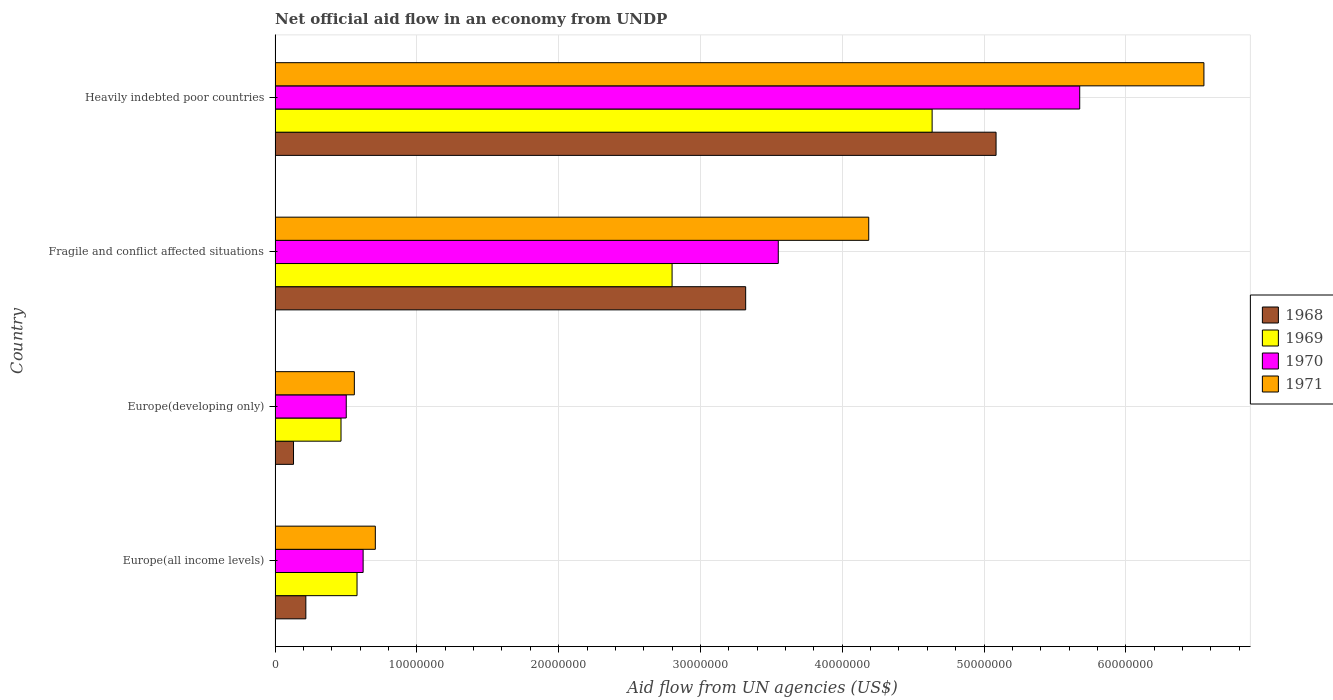Are the number of bars per tick equal to the number of legend labels?
Ensure brevity in your answer.  Yes. How many bars are there on the 3rd tick from the top?
Your response must be concise. 4. What is the label of the 3rd group of bars from the top?
Make the answer very short. Europe(developing only). What is the net official aid flow in 1971 in Europe(all income levels)?
Offer a terse response. 7.07e+06. Across all countries, what is the maximum net official aid flow in 1971?
Your response must be concise. 6.55e+07. Across all countries, what is the minimum net official aid flow in 1971?
Offer a very short reply. 5.59e+06. In which country was the net official aid flow in 1971 maximum?
Keep it short and to the point. Heavily indebted poor countries. In which country was the net official aid flow in 1969 minimum?
Keep it short and to the point. Europe(developing only). What is the total net official aid flow in 1971 in the graph?
Your answer should be compact. 1.20e+08. What is the difference between the net official aid flow in 1969 in Europe(all income levels) and that in Heavily indebted poor countries?
Keep it short and to the point. -4.06e+07. What is the difference between the net official aid flow in 1970 in Fragile and conflict affected situations and the net official aid flow in 1968 in Europe(all income levels)?
Make the answer very short. 3.33e+07. What is the average net official aid flow in 1968 per country?
Ensure brevity in your answer.  2.19e+07. What is the difference between the net official aid flow in 1971 and net official aid flow in 1968 in Europe(developing only)?
Your response must be concise. 4.29e+06. What is the ratio of the net official aid flow in 1970 in Europe(all income levels) to that in Fragile and conflict affected situations?
Make the answer very short. 0.17. What is the difference between the highest and the second highest net official aid flow in 1968?
Your answer should be compact. 1.77e+07. What is the difference between the highest and the lowest net official aid flow in 1970?
Provide a short and direct response. 5.17e+07. In how many countries, is the net official aid flow in 1971 greater than the average net official aid flow in 1971 taken over all countries?
Offer a very short reply. 2. Is it the case that in every country, the sum of the net official aid flow in 1969 and net official aid flow in 1970 is greater than the sum of net official aid flow in 1971 and net official aid flow in 1968?
Offer a very short reply. Yes. What does the 4th bar from the bottom in Heavily indebted poor countries represents?
Your response must be concise. 1971. Are all the bars in the graph horizontal?
Offer a very short reply. Yes. Does the graph contain grids?
Provide a succinct answer. Yes. How many legend labels are there?
Make the answer very short. 4. How are the legend labels stacked?
Offer a terse response. Vertical. What is the title of the graph?
Your answer should be compact. Net official aid flow in an economy from UNDP. Does "2002" appear as one of the legend labels in the graph?
Your answer should be compact. No. What is the label or title of the X-axis?
Offer a very short reply. Aid flow from UN agencies (US$). What is the label or title of the Y-axis?
Give a very brief answer. Country. What is the Aid flow from UN agencies (US$) in 1968 in Europe(all income levels)?
Give a very brief answer. 2.17e+06. What is the Aid flow from UN agencies (US$) in 1969 in Europe(all income levels)?
Your answer should be very brief. 5.78e+06. What is the Aid flow from UN agencies (US$) of 1970 in Europe(all income levels)?
Give a very brief answer. 6.21e+06. What is the Aid flow from UN agencies (US$) of 1971 in Europe(all income levels)?
Your answer should be compact. 7.07e+06. What is the Aid flow from UN agencies (US$) of 1968 in Europe(developing only)?
Offer a terse response. 1.30e+06. What is the Aid flow from UN agencies (US$) in 1969 in Europe(developing only)?
Your answer should be compact. 4.65e+06. What is the Aid flow from UN agencies (US$) in 1970 in Europe(developing only)?
Your answer should be very brief. 5.02e+06. What is the Aid flow from UN agencies (US$) of 1971 in Europe(developing only)?
Your answer should be compact. 5.59e+06. What is the Aid flow from UN agencies (US$) of 1968 in Fragile and conflict affected situations?
Your answer should be compact. 3.32e+07. What is the Aid flow from UN agencies (US$) of 1969 in Fragile and conflict affected situations?
Provide a short and direct response. 2.80e+07. What is the Aid flow from UN agencies (US$) of 1970 in Fragile and conflict affected situations?
Your answer should be very brief. 3.55e+07. What is the Aid flow from UN agencies (US$) of 1971 in Fragile and conflict affected situations?
Your response must be concise. 4.19e+07. What is the Aid flow from UN agencies (US$) of 1968 in Heavily indebted poor countries?
Offer a very short reply. 5.08e+07. What is the Aid flow from UN agencies (US$) of 1969 in Heavily indebted poor countries?
Your response must be concise. 4.63e+07. What is the Aid flow from UN agencies (US$) in 1970 in Heavily indebted poor countries?
Your answer should be compact. 5.68e+07. What is the Aid flow from UN agencies (US$) of 1971 in Heavily indebted poor countries?
Ensure brevity in your answer.  6.55e+07. Across all countries, what is the maximum Aid flow from UN agencies (US$) of 1968?
Your response must be concise. 5.08e+07. Across all countries, what is the maximum Aid flow from UN agencies (US$) in 1969?
Ensure brevity in your answer.  4.63e+07. Across all countries, what is the maximum Aid flow from UN agencies (US$) in 1970?
Offer a terse response. 5.68e+07. Across all countries, what is the maximum Aid flow from UN agencies (US$) in 1971?
Provide a succinct answer. 6.55e+07. Across all countries, what is the minimum Aid flow from UN agencies (US$) of 1968?
Offer a very short reply. 1.30e+06. Across all countries, what is the minimum Aid flow from UN agencies (US$) in 1969?
Your answer should be compact. 4.65e+06. Across all countries, what is the minimum Aid flow from UN agencies (US$) in 1970?
Give a very brief answer. 5.02e+06. Across all countries, what is the minimum Aid flow from UN agencies (US$) in 1971?
Provide a succinct answer. 5.59e+06. What is the total Aid flow from UN agencies (US$) of 1968 in the graph?
Offer a terse response. 8.75e+07. What is the total Aid flow from UN agencies (US$) of 1969 in the graph?
Give a very brief answer. 8.48e+07. What is the total Aid flow from UN agencies (US$) in 1970 in the graph?
Your answer should be compact. 1.03e+08. What is the total Aid flow from UN agencies (US$) in 1971 in the graph?
Make the answer very short. 1.20e+08. What is the difference between the Aid flow from UN agencies (US$) in 1968 in Europe(all income levels) and that in Europe(developing only)?
Offer a terse response. 8.70e+05. What is the difference between the Aid flow from UN agencies (US$) in 1969 in Europe(all income levels) and that in Europe(developing only)?
Make the answer very short. 1.13e+06. What is the difference between the Aid flow from UN agencies (US$) of 1970 in Europe(all income levels) and that in Europe(developing only)?
Keep it short and to the point. 1.19e+06. What is the difference between the Aid flow from UN agencies (US$) in 1971 in Europe(all income levels) and that in Europe(developing only)?
Offer a very short reply. 1.48e+06. What is the difference between the Aid flow from UN agencies (US$) of 1968 in Europe(all income levels) and that in Fragile and conflict affected situations?
Keep it short and to the point. -3.10e+07. What is the difference between the Aid flow from UN agencies (US$) in 1969 in Europe(all income levels) and that in Fragile and conflict affected situations?
Make the answer very short. -2.22e+07. What is the difference between the Aid flow from UN agencies (US$) in 1970 in Europe(all income levels) and that in Fragile and conflict affected situations?
Offer a terse response. -2.93e+07. What is the difference between the Aid flow from UN agencies (US$) in 1971 in Europe(all income levels) and that in Fragile and conflict affected situations?
Your answer should be very brief. -3.48e+07. What is the difference between the Aid flow from UN agencies (US$) of 1968 in Europe(all income levels) and that in Heavily indebted poor countries?
Your answer should be very brief. -4.87e+07. What is the difference between the Aid flow from UN agencies (US$) in 1969 in Europe(all income levels) and that in Heavily indebted poor countries?
Give a very brief answer. -4.06e+07. What is the difference between the Aid flow from UN agencies (US$) of 1970 in Europe(all income levels) and that in Heavily indebted poor countries?
Give a very brief answer. -5.05e+07. What is the difference between the Aid flow from UN agencies (US$) in 1971 in Europe(all income levels) and that in Heavily indebted poor countries?
Your response must be concise. -5.84e+07. What is the difference between the Aid flow from UN agencies (US$) of 1968 in Europe(developing only) and that in Fragile and conflict affected situations?
Ensure brevity in your answer.  -3.19e+07. What is the difference between the Aid flow from UN agencies (US$) in 1969 in Europe(developing only) and that in Fragile and conflict affected situations?
Offer a very short reply. -2.34e+07. What is the difference between the Aid flow from UN agencies (US$) of 1970 in Europe(developing only) and that in Fragile and conflict affected situations?
Your response must be concise. -3.05e+07. What is the difference between the Aid flow from UN agencies (US$) in 1971 in Europe(developing only) and that in Fragile and conflict affected situations?
Give a very brief answer. -3.63e+07. What is the difference between the Aid flow from UN agencies (US$) of 1968 in Europe(developing only) and that in Heavily indebted poor countries?
Keep it short and to the point. -4.96e+07. What is the difference between the Aid flow from UN agencies (US$) in 1969 in Europe(developing only) and that in Heavily indebted poor countries?
Ensure brevity in your answer.  -4.17e+07. What is the difference between the Aid flow from UN agencies (US$) in 1970 in Europe(developing only) and that in Heavily indebted poor countries?
Offer a terse response. -5.17e+07. What is the difference between the Aid flow from UN agencies (US$) in 1971 in Europe(developing only) and that in Heavily indebted poor countries?
Make the answer very short. -5.99e+07. What is the difference between the Aid flow from UN agencies (US$) in 1968 in Fragile and conflict affected situations and that in Heavily indebted poor countries?
Give a very brief answer. -1.77e+07. What is the difference between the Aid flow from UN agencies (US$) in 1969 in Fragile and conflict affected situations and that in Heavily indebted poor countries?
Ensure brevity in your answer.  -1.83e+07. What is the difference between the Aid flow from UN agencies (US$) in 1970 in Fragile and conflict affected situations and that in Heavily indebted poor countries?
Ensure brevity in your answer.  -2.13e+07. What is the difference between the Aid flow from UN agencies (US$) of 1971 in Fragile and conflict affected situations and that in Heavily indebted poor countries?
Your answer should be very brief. -2.36e+07. What is the difference between the Aid flow from UN agencies (US$) in 1968 in Europe(all income levels) and the Aid flow from UN agencies (US$) in 1969 in Europe(developing only)?
Your response must be concise. -2.48e+06. What is the difference between the Aid flow from UN agencies (US$) in 1968 in Europe(all income levels) and the Aid flow from UN agencies (US$) in 1970 in Europe(developing only)?
Offer a terse response. -2.85e+06. What is the difference between the Aid flow from UN agencies (US$) in 1968 in Europe(all income levels) and the Aid flow from UN agencies (US$) in 1971 in Europe(developing only)?
Give a very brief answer. -3.42e+06. What is the difference between the Aid flow from UN agencies (US$) of 1969 in Europe(all income levels) and the Aid flow from UN agencies (US$) of 1970 in Europe(developing only)?
Keep it short and to the point. 7.60e+05. What is the difference between the Aid flow from UN agencies (US$) in 1969 in Europe(all income levels) and the Aid flow from UN agencies (US$) in 1971 in Europe(developing only)?
Provide a short and direct response. 1.90e+05. What is the difference between the Aid flow from UN agencies (US$) of 1970 in Europe(all income levels) and the Aid flow from UN agencies (US$) of 1971 in Europe(developing only)?
Keep it short and to the point. 6.20e+05. What is the difference between the Aid flow from UN agencies (US$) of 1968 in Europe(all income levels) and the Aid flow from UN agencies (US$) of 1969 in Fragile and conflict affected situations?
Your response must be concise. -2.58e+07. What is the difference between the Aid flow from UN agencies (US$) of 1968 in Europe(all income levels) and the Aid flow from UN agencies (US$) of 1970 in Fragile and conflict affected situations?
Ensure brevity in your answer.  -3.33e+07. What is the difference between the Aid flow from UN agencies (US$) of 1968 in Europe(all income levels) and the Aid flow from UN agencies (US$) of 1971 in Fragile and conflict affected situations?
Ensure brevity in your answer.  -3.97e+07. What is the difference between the Aid flow from UN agencies (US$) in 1969 in Europe(all income levels) and the Aid flow from UN agencies (US$) in 1970 in Fragile and conflict affected situations?
Keep it short and to the point. -2.97e+07. What is the difference between the Aid flow from UN agencies (US$) in 1969 in Europe(all income levels) and the Aid flow from UN agencies (US$) in 1971 in Fragile and conflict affected situations?
Provide a short and direct response. -3.61e+07. What is the difference between the Aid flow from UN agencies (US$) of 1970 in Europe(all income levels) and the Aid flow from UN agencies (US$) of 1971 in Fragile and conflict affected situations?
Offer a terse response. -3.57e+07. What is the difference between the Aid flow from UN agencies (US$) in 1968 in Europe(all income levels) and the Aid flow from UN agencies (US$) in 1969 in Heavily indebted poor countries?
Provide a short and direct response. -4.42e+07. What is the difference between the Aid flow from UN agencies (US$) in 1968 in Europe(all income levels) and the Aid flow from UN agencies (US$) in 1970 in Heavily indebted poor countries?
Offer a very short reply. -5.46e+07. What is the difference between the Aid flow from UN agencies (US$) of 1968 in Europe(all income levels) and the Aid flow from UN agencies (US$) of 1971 in Heavily indebted poor countries?
Provide a succinct answer. -6.33e+07. What is the difference between the Aid flow from UN agencies (US$) of 1969 in Europe(all income levels) and the Aid flow from UN agencies (US$) of 1970 in Heavily indebted poor countries?
Give a very brief answer. -5.10e+07. What is the difference between the Aid flow from UN agencies (US$) of 1969 in Europe(all income levels) and the Aid flow from UN agencies (US$) of 1971 in Heavily indebted poor countries?
Offer a very short reply. -5.97e+07. What is the difference between the Aid flow from UN agencies (US$) in 1970 in Europe(all income levels) and the Aid flow from UN agencies (US$) in 1971 in Heavily indebted poor countries?
Offer a very short reply. -5.93e+07. What is the difference between the Aid flow from UN agencies (US$) of 1968 in Europe(developing only) and the Aid flow from UN agencies (US$) of 1969 in Fragile and conflict affected situations?
Make the answer very short. -2.67e+07. What is the difference between the Aid flow from UN agencies (US$) of 1968 in Europe(developing only) and the Aid flow from UN agencies (US$) of 1970 in Fragile and conflict affected situations?
Keep it short and to the point. -3.42e+07. What is the difference between the Aid flow from UN agencies (US$) of 1968 in Europe(developing only) and the Aid flow from UN agencies (US$) of 1971 in Fragile and conflict affected situations?
Keep it short and to the point. -4.06e+07. What is the difference between the Aid flow from UN agencies (US$) of 1969 in Europe(developing only) and the Aid flow from UN agencies (US$) of 1970 in Fragile and conflict affected situations?
Your answer should be compact. -3.08e+07. What is the difference between the Aid flow from UN agencies (US$) in 1969 in Europe(developing only) and the Aid flow from UN agencies (US$) in 1971 in Fragile and conflict affected situations?
Make the answer very short. -3.72e+07. What is the difference between the Aid flow from UN agencies (US$) of 1970 in Europe(developing only) and the Aid flow from UN agencies (US$) of 1971 in Fragile and conflict affected situations?
Offer a very short reply. -3.68e+07. What is the difference between the Aid flow from UN agencies (US$) of 1968 in Europe(developing only) and the Aid flow from UN agencies (US$) of 1969 in Heavily indebted poor countries?
Ensure brevity in your answer.  -4.50e+07. What is the difference between the Aid flow from UN agencies (US$) in 1968 in Europe(developing only) and the Aid flow from UN agencies (US$) in 1970 in Heavily indebted poor countries?
Provide a succinct answer. -5.54e+07. What is the difference between the Aid flow from UN agencies (US$) of 1968 in Europe(developing only) and the Aid flow from UN agencies (US$) of 1971 in Heavily indebted poor countries?
Offer a terse response. -6.42e+07. What is the difference between the Aid flow from UN agencies (US$) in 1969 in Europe(developing only) and the Aid flow from UN agencies (US$) in 1970 in Heavily indebted poor countries?
Offer a terse response. -5.21e+07. What is the difference between the Aid flow from UN agencies (US$) of 1969 in Europe(developing only) and the Aid flow from UN agencies (US$) of 1971 in Heavily indebted poor countries?
Give a very brief answer. -6.09e+07. What is the difference between the Aid flow from UN agencies (US$) of 1970 in Europe(developing only) and the Aid flow from UN agencies (US$) of 1971 in Heavily indebted poor countries?
Offer a very short reply. -6.05e+07. What is the difference between the Aid flow from UN agencies (US$) in 1968 in Fragile and conflict affected situations and the Aid flow from UN agencies (US$) in 1969 in Heavily indebted poor countries?
Your response must be concise. -1.32e+07. What is the difference between the Aid flow from UN agencies (US$) in 1968 in Fragile and conflict affected situations and the Aid flow from UN agencies (US$) in 1970 in Heavily indebted poor countries?
Your answer should be compact. -2.36e+07. What is the difference between the Aid flow from UN agencies (US$) in 1968 in Fragile and conflict affected situations and the Aid flow from UN agencies (US$) in 1971 in Heavily indebted poor countries?
Your response must be concise. -3.23e+07. What is the difference between the Aid flow from UN agencies (US$) of 1969 in Fragile and conflict affected situations and the Aid flow from UN agencies (US$) of 1970 in Heavily indebted poor countries?
Offer a terse response. -2.88e+07. What is the difference between the Aid flow from UN agencies (US$) in 1969 in Fragile and conflict affected situations and the Aid flow from UN agencies (US$) in 1971 in Heavily indebted poor countries?
Your answer should be very brief. -3.75e+07. What is the difference between the Aid flow from UN agencies (US$) of 1970 in Fragile and conflict affected situations and the Aid flow from UN agencies (US$) of 1971 in Heavily indebted poor countries?
Keep it short and to the point. -3.00e+07. What is the average Aid flow from UN agencies (US$) in 1968 per country?
Ensure brevity in your answer.  2.19e+07. What is the average Aid flow from UN agencies (US$) of 1969 per country?
Offer a very short reply. 2.12e+07. What is the average Aid flow from UN agencies (US$) in 1970 per country?
Give a very brief answer. 2.59e+07. What is the average Aid flow from UN agencies (US$) in 1971 per country?
Offer a very short reply. 3.00e+07. What is the difference between the Aid flow from UN agencies (US$) in 1968 and Aid flow from UN agencies (US$) in 1969 in Europe(all income levels)?
Give a very brief answer. -3.61e+06. What is the difference between the Aid flow from UN agencies (US$) in 1968 and Aid flow from UN agencies (US$) in 1970 in Europe(all income levels)?
Provide a succinct answer. -4.04e+06. What is the difference between the Aid flow from UN agencies (US$) in 1968 and Aid flow from UN agencies (US$) in 1971 in Europe(all income levels)?
Provide a succinct answer. -4.90e+06. What is the difference between the Aid flow from UN agencies (US$) of 1969 and Aid flow from UN agencies (US$) of 1970 in Europe(all income levels)?
Provide a succinct answer. -4.30e+05. What is the difference between the Aid flow from UN agencies (US$) of 1969 and Aid flow from UN agencies (US$) of 1971 in Europe(all income levels)?
Your answer should be compact. -1.29e+06. What is the difference between the Aid flow from UN agencies (US$) of 1970 and Aid flow from UN agencies (US$) of 1971 in Europe(all income levels)?
Offer a terse response. -8.60e+05. What is the difference between the Aid flow from UN agencies (US$) of 1968 and Aid flow from UN agencies (US$) of 1969 in Europe(developing only)?
Your response must be concise. -3.35e+06. What is the difference between the Aid flow from UN agencies (US$) of 1968 and Aid flow from UN agencies (US$) of 1970 in Europe(developing only)?
Offer a very short reply. -3.72e+06. What is the difference between the Aid flow from UN agencies (US$) of 1968 and Aid flow from UN agencies (US$) of 1971 in Europe(developing only)?
Offer a very short reply. -4.29e+06. What is the difference between the Aid flow from UN agencies (US$) of 1969 and Aid flow from UN agencies (US$) of 1970 in Europe(developing only)?
Offer a terse response. -3.70e+05. What is the difference between the Aid flow from UN agencies (US$) in 1969 and Aid flow from UN agencies (US$) in 1971 in Europe(developing only)?
Provide a succinct answer. -9.40e+05. What is the difference between the Aid flow from UN agencies (US$) in 1970 and Aid flow from UN agencies (US$) in 1971 in Europe(developing only)?
Provide a succinct answer. -5.70e+05. What is the difference between the Aid flow from UN agencies (US$) of 1968 and Aid flow from UN agencies (US$) of 1969 in Fragile and conflict affected situations?
Ensure brevity in your answer.  5.19e+06. What is the difference between the Aid flow from UN agencies (US$) in 1968 and Aid flow from UN agencies (US$) in 1970 in Fragile and conflict affected situations?
Ensure brevity in your answer.  -2.30e+06. What is the difference between the Aid flow from UN agencies (US$) in 1968 and Aid flow from UN agencies (US$) in 1971 in Fragile and conflict affected situations?
Your answer should be compact. -8.68e+06. What is the difference between the Aid flow from UN agencies (US$) of 1969 and Aid flow from UN agencies (US$) of 1970 in Fragile and conflict affected situations?
Offer a terse response. -7.49e+06. What is the difference between the Aid flow from UN agencies (US$) of 1969 and Aid flow from UN agencies (US$) of 1971 in Fragile and conflict affected situations?
Offer a very short reply. -1.39e+07. What is the difference between the Aid flow from UN agencies (US$) in 1970 and Aid flow from UN agencies (US$) in 1971 in Fragile and conflict affected situations?
Keep it short and to the point. -6.38e+06. What is the difference between the Aid flow from UN agencies (US$) in 1968 and Aid flow from UN agencies (US$) in 1969 in Heavily indebted poor countries?
Your answer should be compact. 4.51e+06. What is the difference between the Aid flow from UN agencies (US$) in 1968 and Aid flow from UN agencies (US$) in 1970 in Heavily indebted poor countries?
Keep it short and to the point. -5.90e+06. What is the difference between the Aid flow from UN agencies (US$) in 1968 and Aid flow from UN agencies (US$) in 1971 in Heavily indebted poor countries?
Offer a very short reply. -1.47e+07. What is the difference between the Aid flow from UN agencies (US$) of 1969 and Aid flow from UN agencies (US$) of 1970 in Heavily indebted poor countries?
Your answer should be very brief. -1.04e+07. What is the difference between the Aid flow from UN agencies (US$) in 1969 and Aid flow from UN agencies (US$) in 1971 in Heavily indebted poor countries?
Make the answer very short. -1.92e+07. What is the difference between the Aid flow from UN agencies (US$) of 1970 and Aid flow from UN agencies (US$) of 1971 in Heavily indebted poor countries?
Provide a succinct answer. -8.76e+06. What is the ratio of the Aid flow from UN agencies (US$) of 1968 in Europe(all income levels) to that in Europe(developing only)?
Provide a short and direct response. 1.67. What is the ratio of the Aid flow from UN agencies (US$) in 1969 in Europe(all income levels) to that in Europe(developing only)?
Make the answer very short. 1.24. What is the ratio of the Aid flow from UN agencies (US$) of 1970 in Europe(all income levels) to that in Europe(developing only)?
Provide a succinct answer. 1.24. What is the ratio of the Aid flow from UN agencies (US$) of 1971 in Europe(all income levels) to that in Europe(developing only)?
Your answer should be compact. 1.26. What is the ratio of the Aid flow from UN agencies (US$) of 1968 in Europe(all income levels) to that in Fragile and conflict affected situations?
Provide a short and direct response. 0.07. What is the ratio of the Aid flow from UN agencies (US$) of 1969 in Europe(all income levels) to that in Fragile and conflict affected situations?
Provide a short and direct response. 0.21. What is the ratio of the Aid flow from UN agencies (US$) in 1970 in Europe(all income levels) to that in Fragile and conflict affected situations?
Give a very brief answer. 0.17. What is the ratio of the Aid flow from UN agencies (US$) of 1971 in Europe(all income levels) to that in Fragile and conflict affected situations?
Give a very brief answer. 0.17. What is the ratio of the Aid flow from UN agencies (US$) in 1968 in Europe(all income levels) to that in Heavily indebted poor countries?
Provide a short and direct response. 0.04. What is the ratio of the Aid flow from UN agencies (US$) of 1969 in Europe(all income levels) to that in Heavily indebted poor countries?
Your answer should be compact. 0.12. What is the ratio of the Aid flow from UN agencies (US$) of 1970 in Europe(all income levels) to that in Heavily indebted poor countries?
Your answer should be compact. 0.11. What is the ratio of the Aid flow from UN agencies (US$) in 1971 in Europe(all income levels) to that in Heavily indebted poor countries?
Your answer should be compact. 0.11. What is the ratio of the Aid flow from UN agencies (US$) in 1968 in Europe(developing only) to that in Fragile and conflict affected situations?
Offer a very short reply. 0.04. What is the ratio of the Aid flow from UN agencies (US$) of 1969 in Europe(developing only) to that in Fragile and conflict affected situations?
Your answer should be compact. 0.17. What is the ratio of the Aid flow from UN agencies (US$) in 1970 in Europe(developing only) to that in Fragile and conflict affected situations?
Provide a short and direct response. 0.14. What is the ratio of the Aid flow from UN agencies (US$) of 1971 in Europe(developing only) to that in Fragile and conflict affected situations?
Provide a short and direct response. 0.13. What is the ratio of the Aid flow from UN agencies (US$) in 1968 in Europe(developing only) to that in Heavily indebted poor countries?
Keep it short and to the point. 0.03. What is the ratio of the Aid flow from UN agencies (US$) in 1969 in Europe(developing only) to that in Heavily indebted poor countries?
Give a very brief answer. 0.1. What is the ratio of the Aid flow from UN agencies (US$) of 1970 in Europe(developing only) to that in Heavily indebted poor countries?
Your answer should be compact. 0.09. What is the ratio of the Aid flow from UN agencies (US$) in 1971 in Europe(developing only) to that in Heavily indebted poor countries?
Make the answer very short. 0.09. What is the ratio of the Aid flow from UN agencies (US$) in 1968 in Fragile and conflict affected situations to that in Heavily indebted poor countries?
Provide a short and direct response. 0.65. What is the ratio of the Aid flow from UN agencies (US$) in 1969 in Fragile and conflict affected situations to that in Heavily indebted poor countries?
Provide a short and direct response. 0.6. What is the ratio of the Aid flow from UN agencies (US$) in 1970 in Fragile and conflict affected situations to that in Heavily indebted poor countries?
Ensure brevity in your answer.  0.63. What is the ratio of the Aid flow from UN agencies (US$) of 1971 in Fragile and conflict affected situations to that in Heavily indebted poor countries?
Your answer should be compact. 0.64. What is the difference between the highest and the second highest Aid flow from UN agencies (US$) of 1968?
Offer a terse response. 1.77e+07. What is the difference between the highest and the second highest Aid flow from UN agencies (US$) of 1969?
Your answer should be very brief. 1.83e+07. What is the difference between the highest and the second highest Aid flow from UN agencies (US$) of 1970?
Your response must be concise. 2.13e+07. What is the difference between the highest and the second highest Aid flow from UN agencies (US$) of 1971?
Ensure brevity in your answer.  2.36e+07. What is the difference between the highest and the lowest Aid flow from UN agencies (US$) in 1968?
Make the answer very short. 4.96e+07. What is the difference between the highest and the lowest Aid flow from UN agencies (US$) in 1969?
Your response must be concise. 4.17e+07. What is the difference between the highest and the lowest Aid flow from UN agencies (US$) in 1970?
Offer a terse response. 5.17e+07. What is the difference between the highest and the lowest Aid flow from UN agencies (US$) in 1971?
Ensure brevity in your answer.  5.99e+07. 